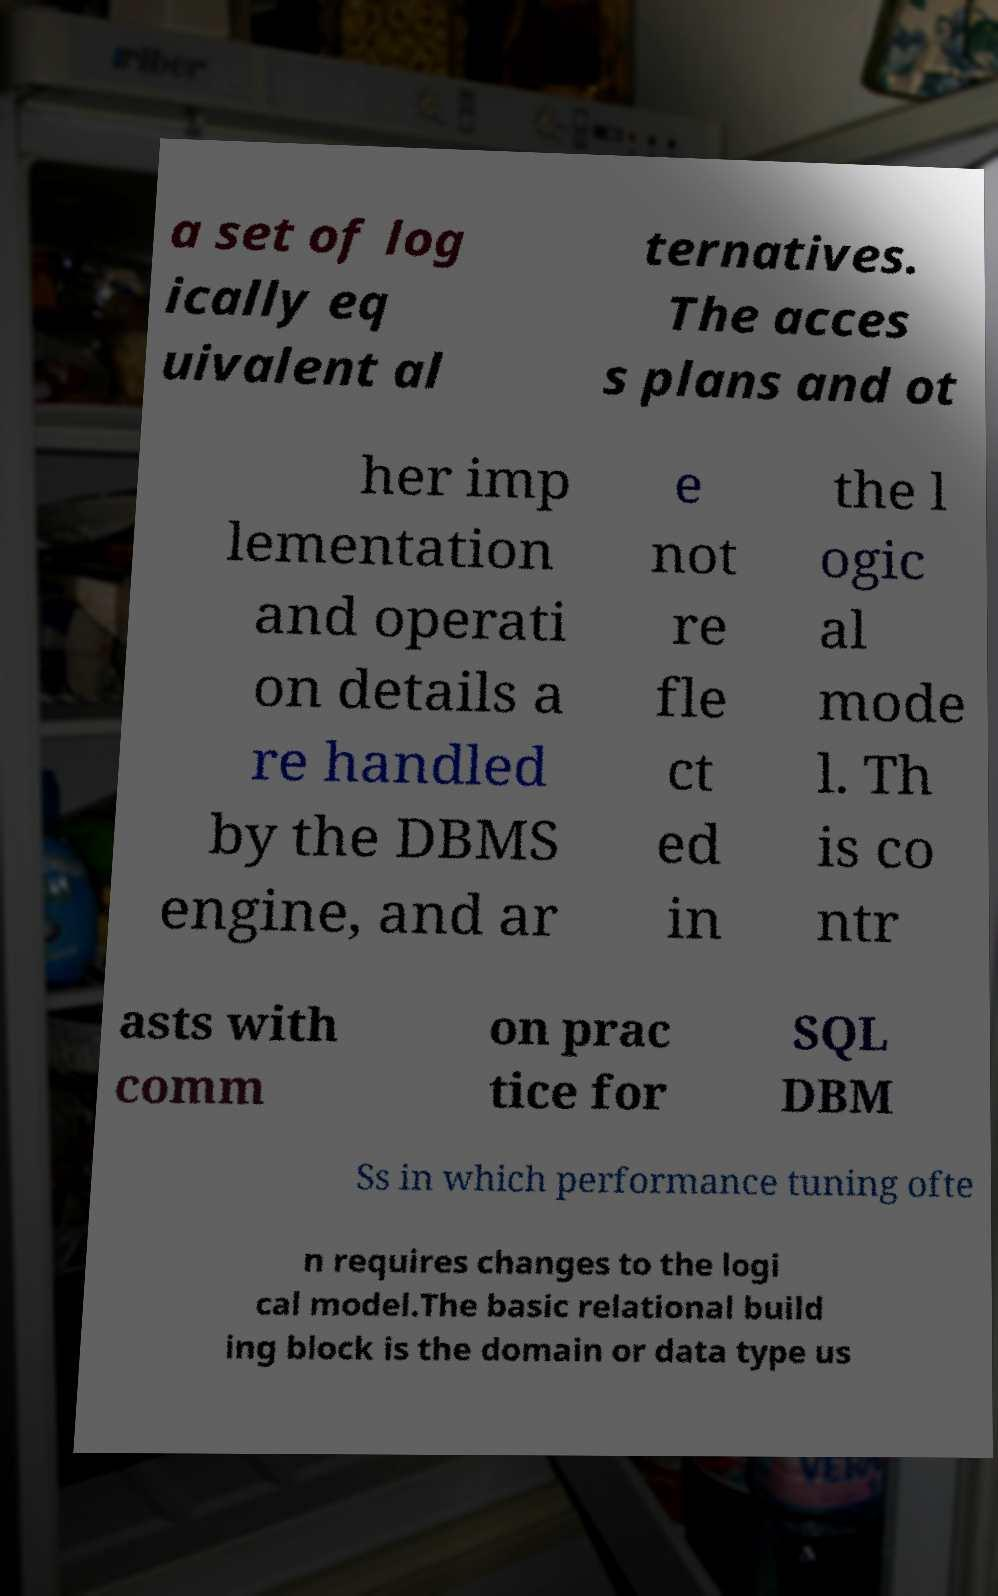I need the written content from this picture converted into text. Can you do that? a set of log ically eq uivalent al ternatives. The acces s plans and ot her imp lementation and operati on details a re handled by the DBMS engine, and ar e not re fle ct ed in the l ogic al mode l. Th is co ntr asts with comm on prac tice for SQL DBM Ss in which performance tuning ofte n requires changes to the logi cal model.The basic relational build ing block is the domain or data type us 